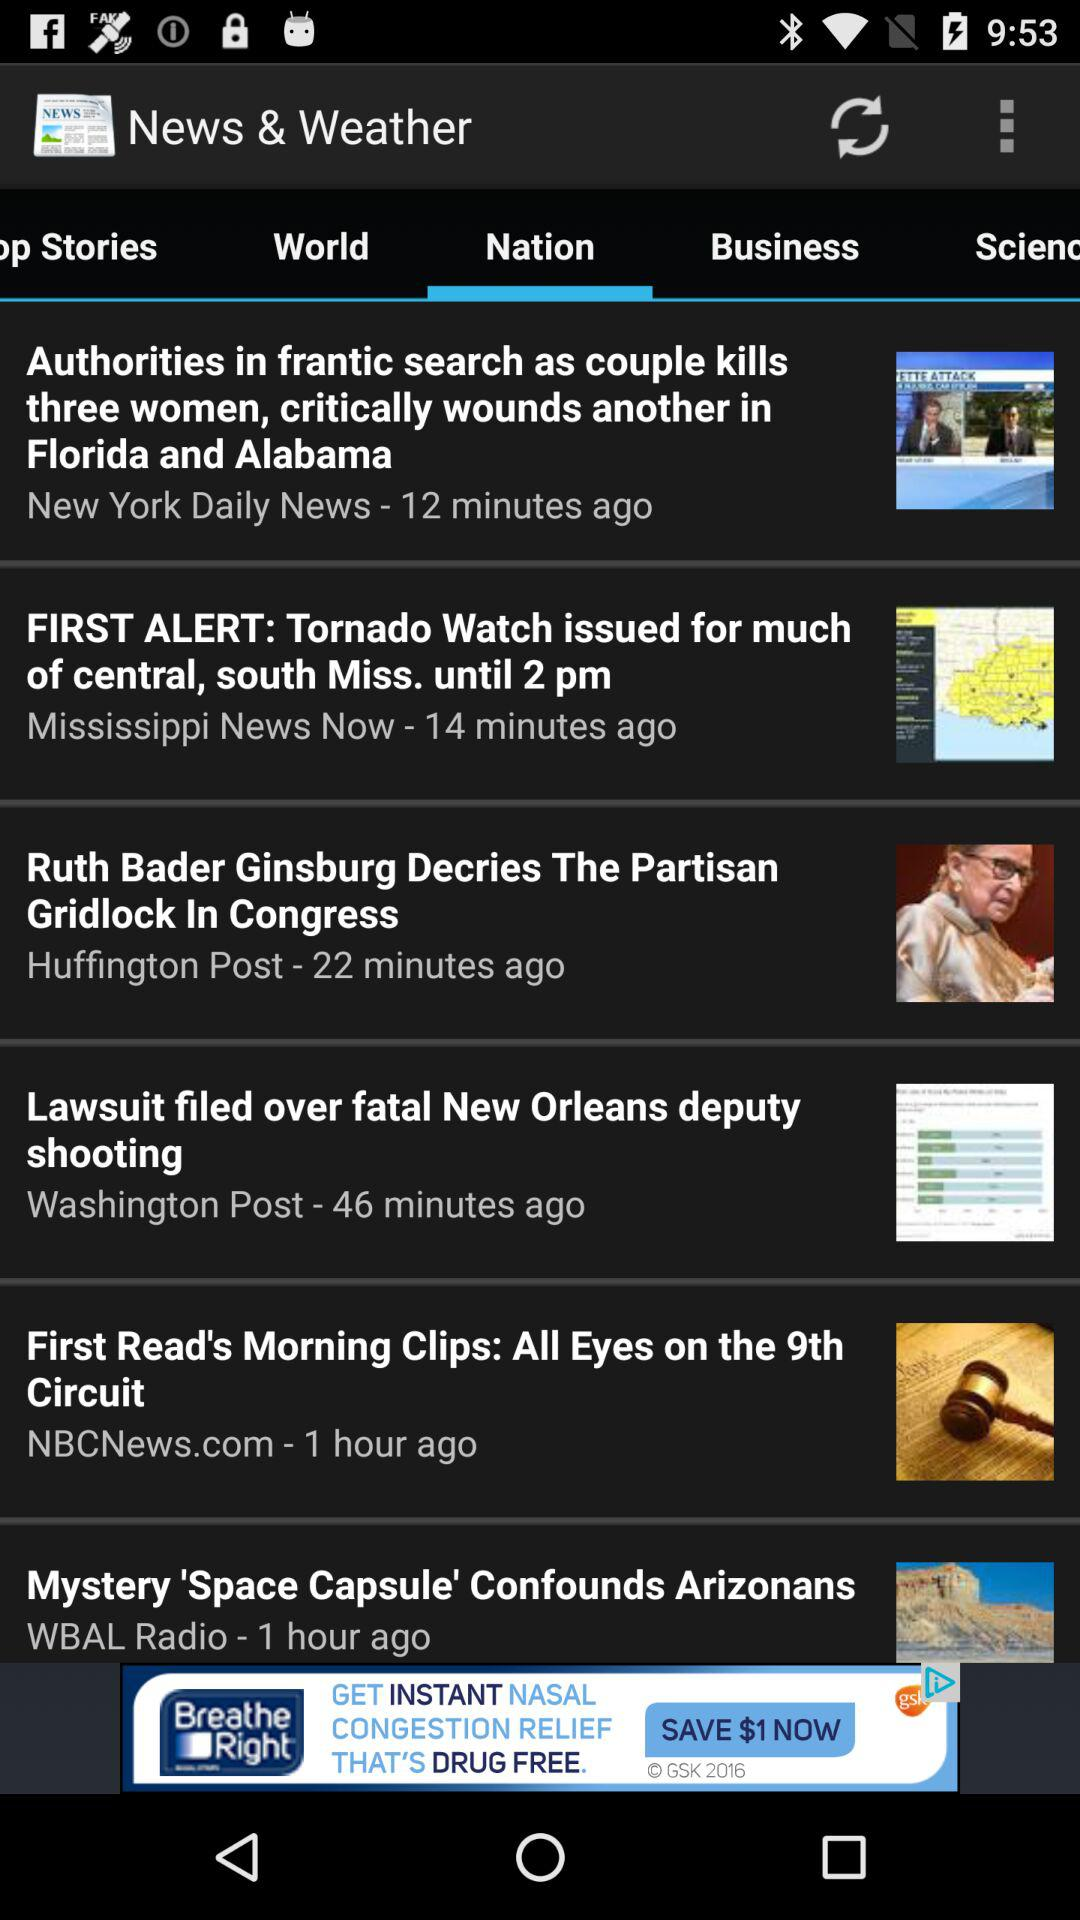How many minutes ago was the news "Lawsuit filed over fatal New Orleans deputy" posted? The news "Lawsuit filed over fatal New Orleans deputy" was posted 46 minutes ago. 